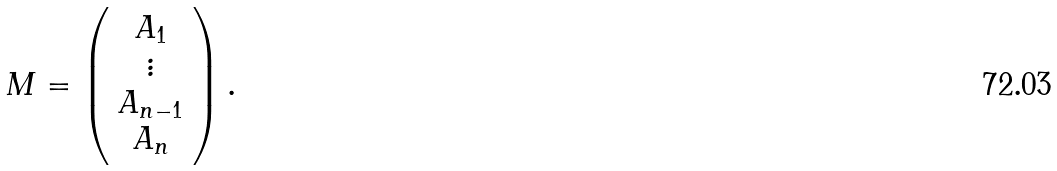<formula> <loc_0><loc_0><loc_500><loc_500>M = \left ( \begin{array} { c } A _ { 1 } \\ \vdots \\ A _ { n - 1 } \\ A _ { n } \end{array} \right ) .</formula> 